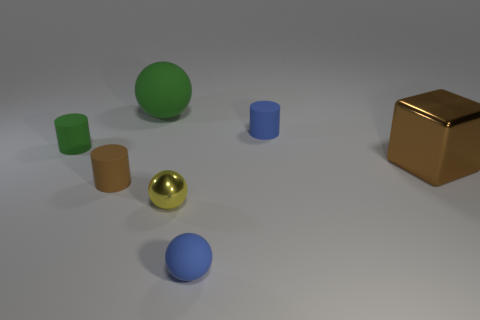There is a rubber ball in front of the blue cylinder; what color is it?
Provide a short and direct response. Blue. How many rubber spheres are the same color as the large matte thing?
Ensure brevity in your answer.  0. How many small objects are both behind the tiny yellow object and right of the big rubber sphere?
Provide a short and direct response. 1. There is a brown thing that is the same size as the metal sphere; what is its shape?
Your answer should be very brief. Cylinder. The yellow metallic object has what size?
Your response must be concise. Small. There is a blue sphere that is in front of the green matte thing that is on the left side of the brown object that is on the left side of the large brown shiny cube; what is its material?
Keep it short and to the point. Rubber. What is the color of the ball that is made of the same material as the large green thing?
Offer a terse response. Blue. There is a blue rubber thing on the right side of the blue thing that is in front of the big shiny thing; what number of small matte spheres are left of it?
Offer a terse response. 1. Is there any other thing that is the same shape as the big shiny thing?
Give a very brief answer. No. What number of objects are either brown objects that are on the right side of the brown cylinder or large objects?
Make the answer very short. 2. 